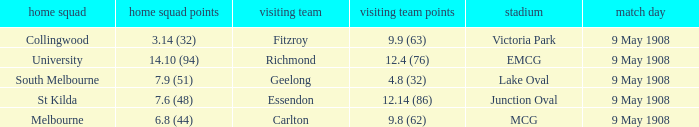Name the home team for carlton away team Melbourne. 